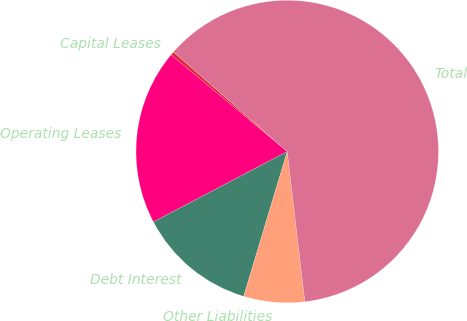<chart> <loc_0><loc_0><loc_500><loc_500><pie_chart><fcel>Capital Leases<fcel>Operating Leases<fcel>Debt Interest<fcel>Other Liabilities<fcel>Total<nl><fcel>0.38%<fcel>18.77%<fcel>12.64%<fcel>6.51%<fcel>61.7%<nl></chart> 